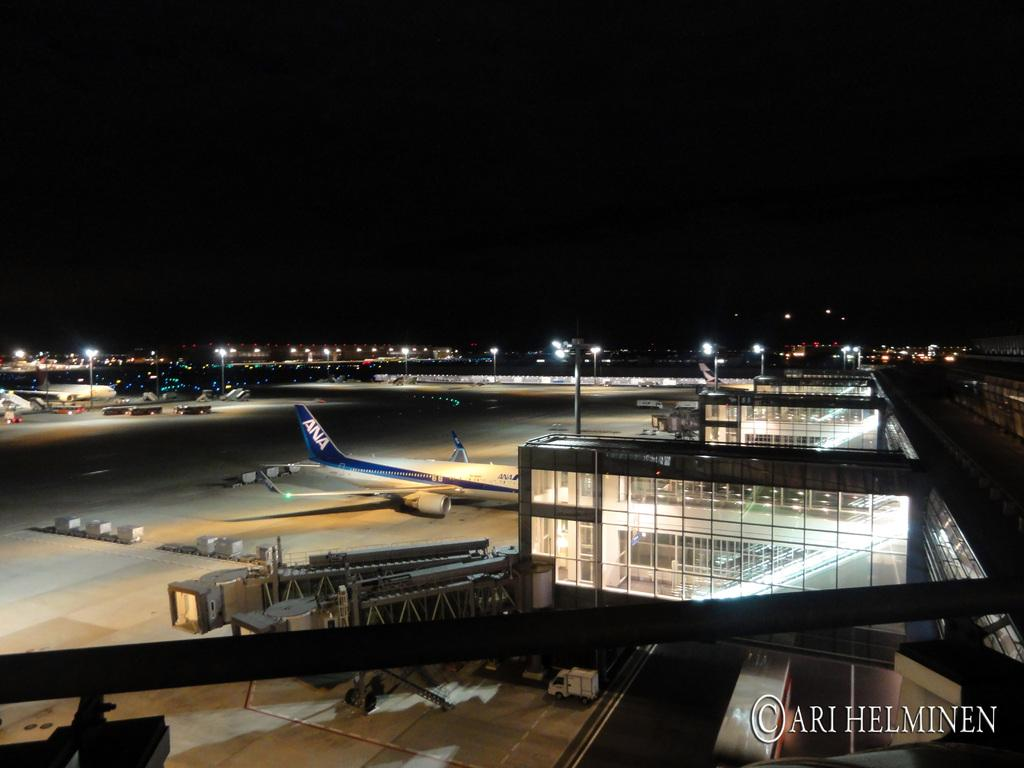What is the main subject of the image? The main subject of the image is an airplane. What other objects can be seen in the image? There are vehicles, buildings, and poles in the image. Is there any text present in the image? Yes, there is text in the bottom right corner of the image. What color is the square of yarn in the image? There is no square of yarn present in the image. 